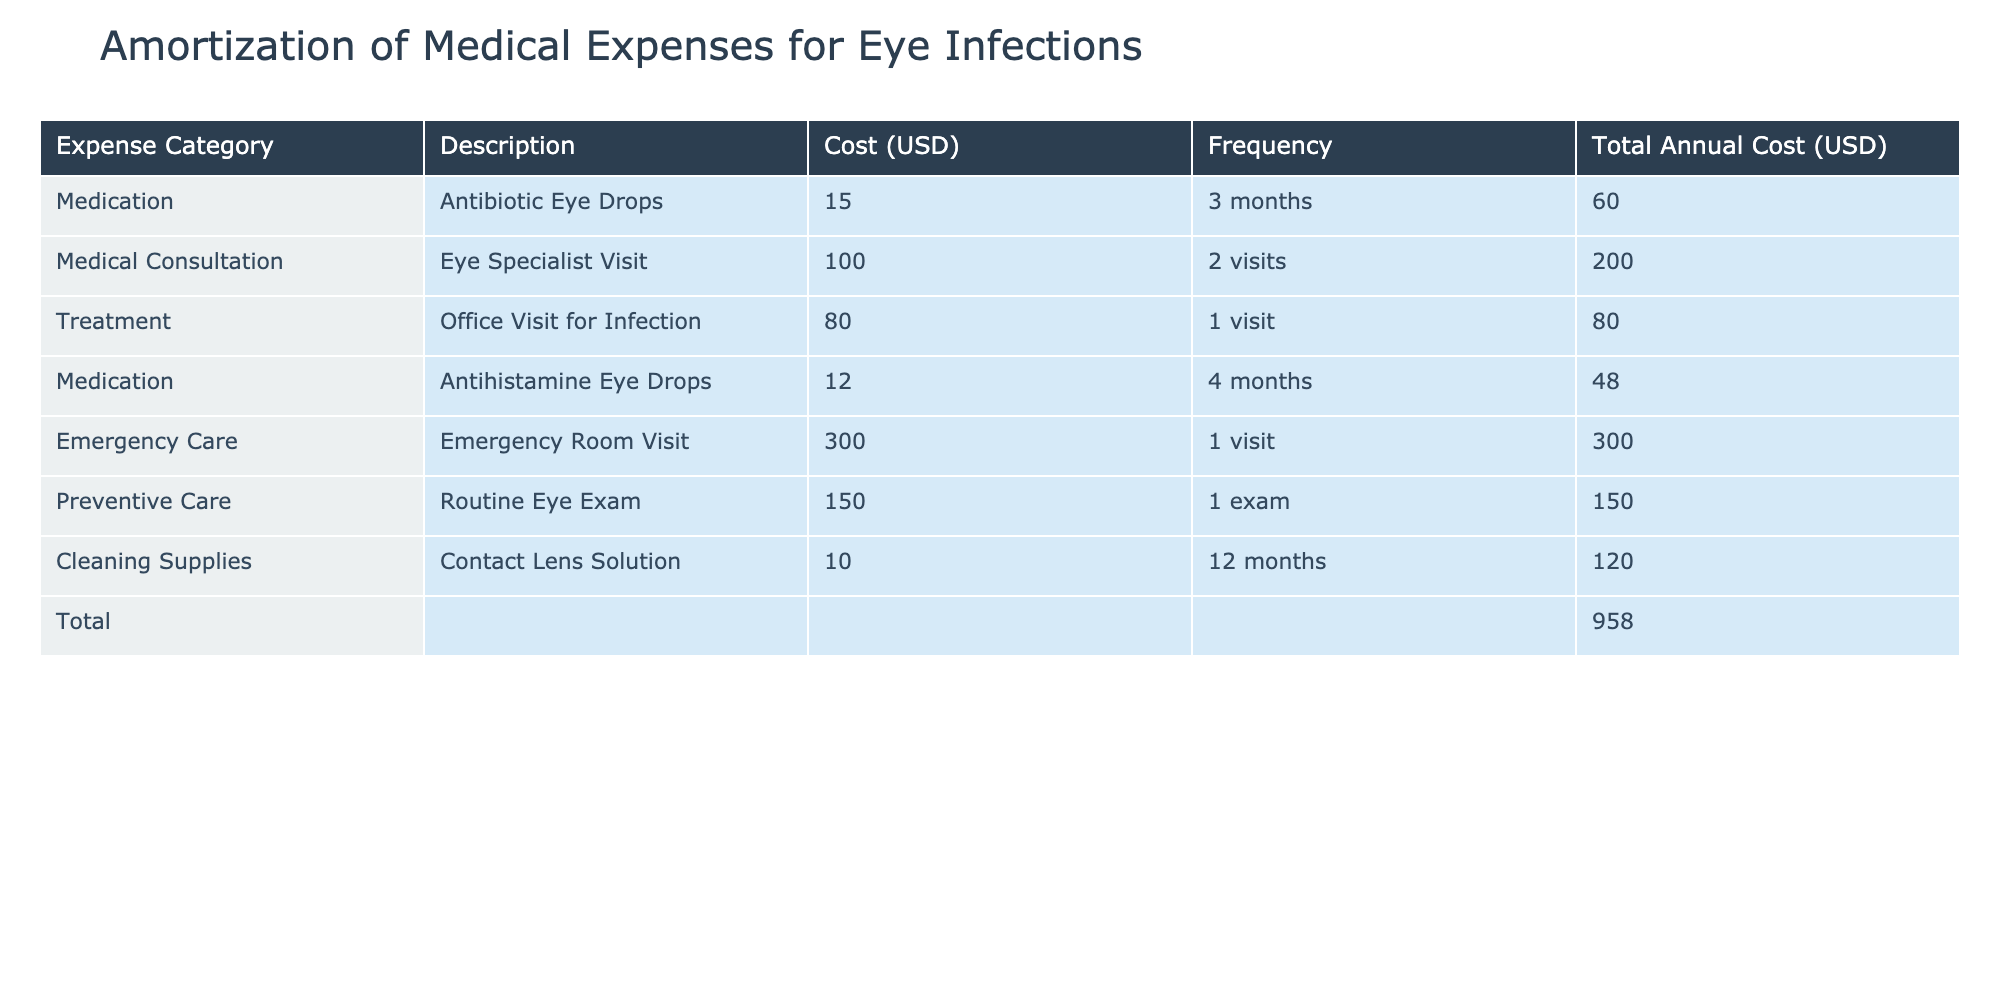What is the total annual cost for medication expenses? To find the total annual cost for medication expenses, we need to sum the 'Total Annual Cost (USD)' for the rows categorized under medication. From the table, the medication expenses are: Antibiotic Eye Drops ($60.00) and Antihistamine Eye Drops ($48.00). Adding these gives us 60 + 48 = 108.00.
Answer: 108.00 How much does an emergency room visit cost? The table provides a specific entry for Emergency Care, which lists the Emergency Room Visit at a cost of $300.00. Therefore, the cost for an emergency room visit is directly given in the table.
Answer: 300.00 Is the cost of the preventive care higher than the total cost for medications? The cost for Preventive Care (Routine Eye Exam) is $150.00, and we already calculated the total cost for medications as $108.00. Since 150.00 is greater than 108.00, this statement is true.
Answer: Yes What category has the highest total annual cost? To determine which category has the highest total annual cost, we look at the total annual costs for each category: Medication ($108.00), Medical Consultation ($200.00), Treatment ($80.00), Emergency Care ($300.00), Preventive Care ($150.00), and Cleaning Supplies ($120.00). The highest total comes from Emergency Care at $300.00.
Answer: Emergency Care What is the average cost of all medical consultations? The total cost for medical consultations includes the Eye Specialist Visit ($200.00) and the Office Visit for Infection ($80.00) for a total of 200 + 80 = 280. There are 2 consultations. To find the average, we divide the total by the number of consultations: 280 / 2 = 140.
Answer: 140.00 What are the total costs of cleaning supplies and preventive care combined? The total cost for Cleaning Supplies (Contact Lens Solution) is $120.00 and for Preventive Care (Routine Eye Exam) is $150.00. Adding these together gives us 120 + 150 = 270.
Answer: 270.00 Were there any expenses related to emergency care? Yes, there is an entry under Emergency Care for an Emergency Room Visit costing $300.00. Therefore, there is indeed an expense related to emergency care in the table.
Answer: Yes Which expense category has the lowest total cost? Looking at the total annual costs for each category, we see: Medication ($108.00), Medical Consultation ($200.00), Treatment ($80.00), Emergency Care ($300.00), Preventive Care ($150.00), and Cleaning Supplies ($120.00). The category with the lowest total cost is Treatment at $80.00.
Answer: Treatment 